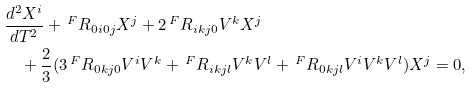<formula> <loc_0><loc_0><loc_500><loc_500>& \frac { d ^ { 2 } X ^ { i } } { d T ^ { 2 } } + \, { ^ { F } R _ { 0 i 0 j } } X ^ { j } + 2 \, { ^ { F } R _ { i k j 0 } } V ^ { k } X ^ { j } \\ & \quad + \frac { 2 } { 3 } ( 3 \, { ^ { F } R _ { 0 k j 0 } } V ^ { i } V ^ { k } + \, { ^ { F } R _ { i k j l } } V ^ { k } V ^ { l } + \, { ^ { F } R _ { 0 k j l } } V ^ { i } V ^ { k } V ^ { l } ) X ^ { j } = 0 ,</formula> 